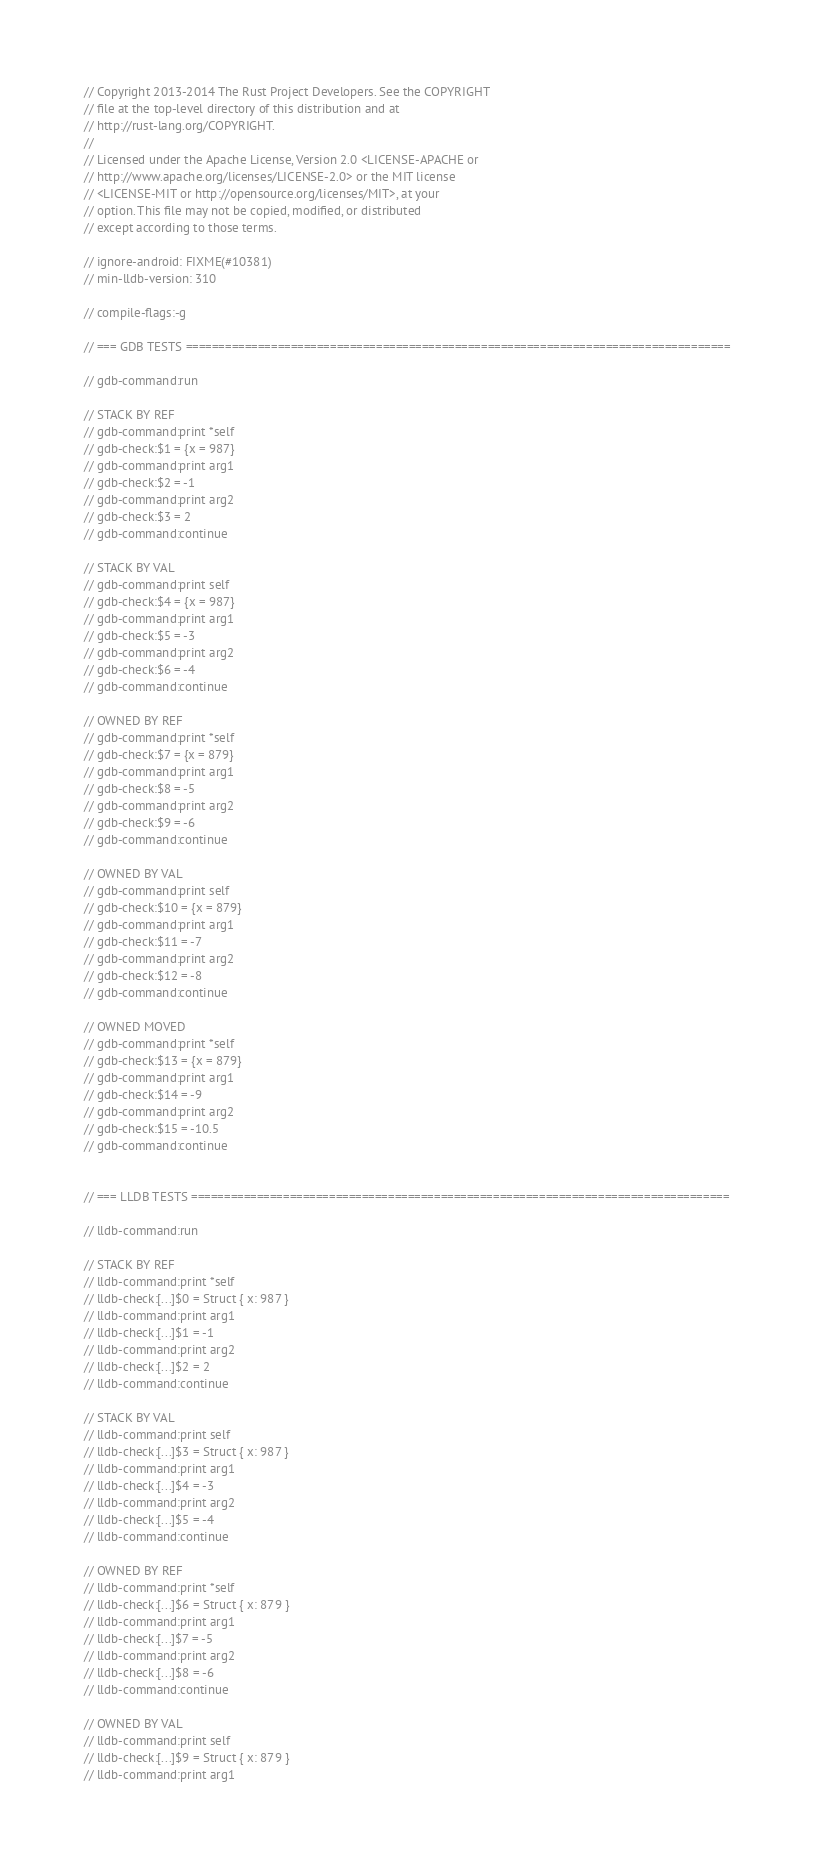Convert code to text. <code><loc_0><loc_0><loc_500><loc_500><_Rust_>// Copyright 2013-2014 The Rust Project Developers. See the COPYRIGHT
// file at the top-level directory of this distribution and at
// http://rust-lang.org/COPYRIGHT.
//
// Licensed under the Apache License, Version 2.0 <LICENSE-APACHE or
// http://www.apache.org/licenses/LICENSE-2.0> or the MIT license
// <LICENSE-MIT or http://opensource.org/licenses/MIT>, at your
// option. This file may not be copied, modified, or distributed
// except according to those terms.

// ignore-android: FIXME(#10381)
// min-lldb-version: 310

// compile-flags:-g

// === GDB TESTS ===================================================================================

// gdb-command:run

// STACK BY REF
// gdb-command:print *self
// gdb-check:$1 = {x = 987}
// gdb-command:print arg1
// gdb-check:$2 = -1
// gdb-command:print arg2
// gdb-check:$3 = 2
// gdb-command:continue

// STACK BY VAL
// gdb-command:print self
// gdb-check:$4 = {x = 987}
// gdb-command:print arg1
// gdb-check:$5 = -3
// gdb-command:print arg2
// gdb-check:$6 = -4
// gdb-command:continue

// OWNED BY REF
// gdb-command:print *self
// gdb-check:$7 = {x = 879}
// gdb-command:print arg1
// gdb-check:$8 = -5
// gdb-command:print arg2
// gdb-check:$9 = -6
// gdb-command:continue

// OWNED BY VAL
// gdb-command:print self
// gdb-check:$10 = {x = 879}
// gdb-command:print arg1
// gdb-check:$11 = -7
// gdb-command:print arg2
// gdb-check:$12 = -8
// gdb-command:continue

// OWNED MOVED
// gdb-command:print *self
// gdb-check:$13 = {x = 879}
// gdb-command:print arg1
// gdb-check:$14 = -9
// gdb-command:print arg2
// gdb-check:$15 = -10.5
// gdb-command:continue


// === LLDB TESTS ==================================================================================

// lldb-command:run

// STACK BY REF
// lldb-command:print *self
// lldb-check:[...]$0 = Struct { x: 987 }
// lldb-command:print arg1
// lldb-check:[...]$1 = -1
// lldb-command:print arg2
// lldb-check:[...]$2 = 2
// lldb-command:continue

// STACK BY VAL
// lldb-command:print self
// lldb-check:[...]$3 = Struct { x: 987 }
// lldb-command:print arg1
// lldb-check:[...]$4 = -3
// lldb-command:print arg2
// lldb-check:[...]$5 = -4
// lldb-command:continue

// OWNED BY REF
// lldb-command:print *self
// lldb-check:[...]$6 = Struct { x: 879 }
// lldb-command:print arg1
// lldb-check:[...]$7 = -5
// lldb-command:print arg2
// lldb-check:[...]$8 = -6
// lldb-command:continue

// OWNED BY VAL
// lldb-command:print self
// lldb-check:[...]$9 = Struct { x: 879 }
// lldb-command:print arg1</code> 